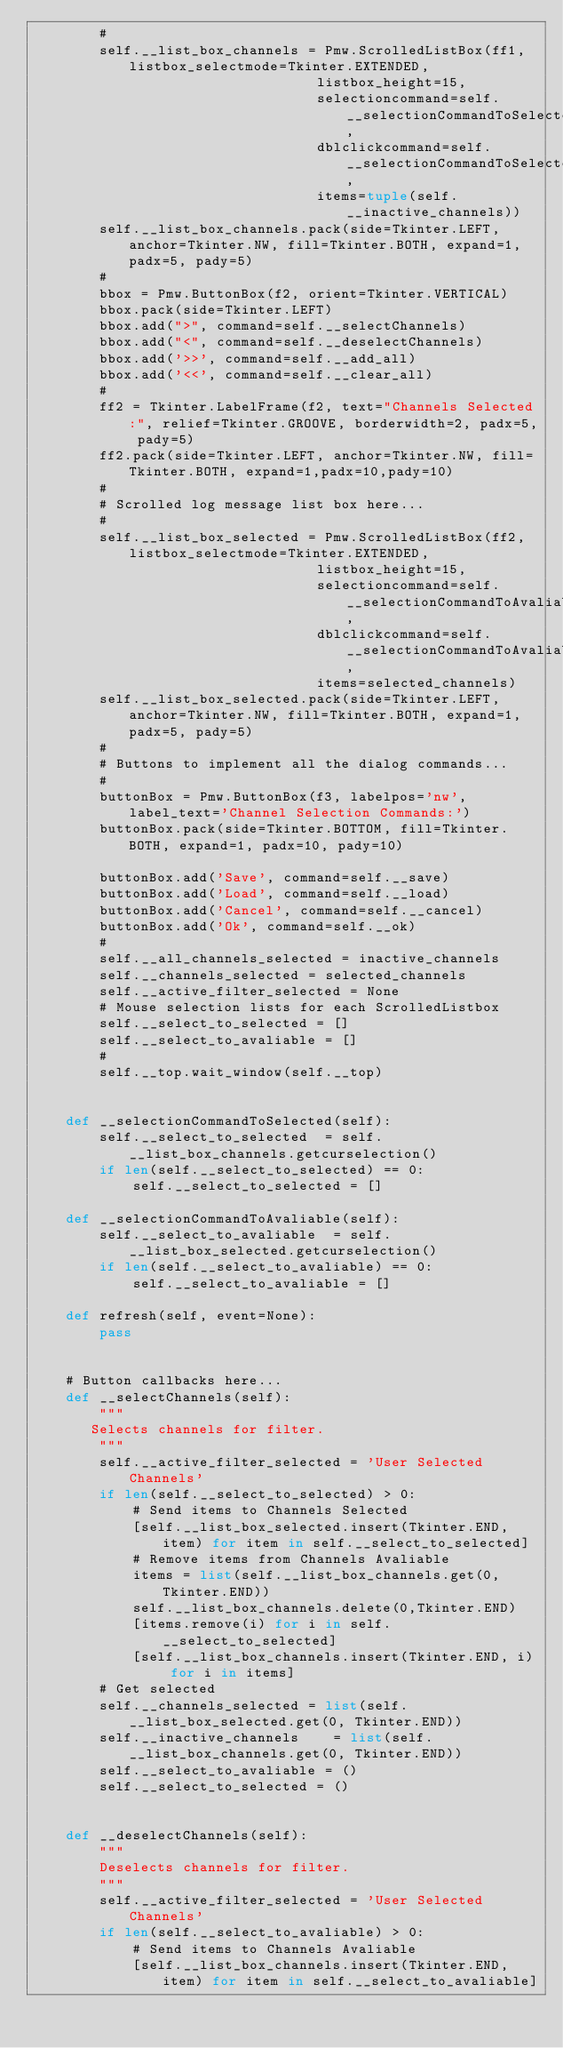<code> <loc_0><loc_0><loc_500><loc_500><_Python_>        #
        self.__list_box_channels = Pmw.ScrolledListBox(ff1, listbox_selectmode=Tkinter.EXTENDED,
                                  listbox_height=15,
                                  selectioncommand=self.__selectionCommandToSelected,
                                  dblclickcommand=self.__selectionCommandToSelected,
                                  items=tuple(self.__inactive_channels))
        self.__list_box_channels.pack(side=Tkinter.LEFT, anchor=Tkinter.NW, fill=Tkinter.BOTH, expand=1, padx=5, pady=5)
        #
        bbox = Pmw.ButtonBox(f2, orient=Tkinter.VERTICAL)
        bbox.pack(side=Tkinter.LEFT)
        bbox.add(">", command=self.__selectChannels)
        bbox.add("<", command=self.__deselectChannels)
        bbox.add('>>', command=self.__add_all)
        bbox.add('<<', command=self.__clear_all)
        #
        ff2 = Tkinter.LabelFrame(f2, text="Channels Selected:", relief=Tkinter.GROOVE, borderwidth=2, padx=5, pady=5)
        ff2.pack(side=Tkinter.LEFT, anchor=Tkinter.NW, fill=Tkinter.BOTH, expand=1,padx=10,pady=10)
        #
        # Scrolled log message list box here...
        #
        self.__list_box_selected = Pmw.ScrolledListBox(ff2, listbox_selectmode=Tkinter.EXTENDED,
                                  listbox_height=15,
                                  selectioncommand=self.__selectionCommandToAvaliable,
                                  dblclickcommand=self.__selectionCommandToAvaliable,
                                  items=selected_channels)
        self.__list_box_selected.pack(side=Tkinter.LEFT, anchor=Tkinter.NW, fill=Tkinter.BOTH, expand=1, padx=5, pady=5)
        #
        # Buttons to implement all the dialog commands...
        #
        buttonBox = Pmw.ButtonBox(f3, labelpos='nw', label_text='Channel Selection Commands:')
        buttonBox.pack(side=Tkinter.BOTTOM, fill=Tkinter.BOTH, expand=1, padx=10, pady=10)

        buttonBox.add('Save', command=self.__save)
        buttonBox.add('Load', command=self.__load)
        buttonBox.add('Cancel', command=self.__cancel)
        buttonBox.add('Ok', command=self.__ok)
        #
        self.__all_channels_selected = inactive_channels
        self.__channels_selected = selected_channels
        self.__active_filter_selected = None
        # Mouse selection lists for each ScrolledListbox
        self.__select_to_selected = []
        self.__select_to_avaliable = []
        #
        self.__top.wait_window(self.__top)


    def __selectionCommandToSelected(self):
        self.__select_to_selected  = self.__list_box_channels.getcurselection()
        if len(self.__select_to_selected) == 0:
            self.__select_to_selected = []

    def __selectionCommandToAvaliable(self):
        self.__select_to_avaliable  = self.__list_box_selected.getcurselection()
        if len(self.__select_to_avaliable) == 0:
            self.__select_to_avaliable = []

    def refresh(self, event=None):
        pass


    # Button callbacks here...
    def __selectChannels(self):
        """
       Selects channels for filter.
        """
        self.__active_filter_selected = 'User Selected Channels'
        if len(self.__select_to_selected) > 0:
            # Send items to Channels Selected
            [self.__list_box_selected.insert(Tkinter.END, item) for item in self.__select_to_selected]
            # Remove items from Channels Avaliable
            items = list(self.__list_box_channels.get(0, Tkinter.END))
            self.__list_box_channels.delete(0,Tkinter.END)
            [items.remove(i) for i in self.__select_to_selected]
            [self.__list_box_channels.insert(Tkinter.END, i) for i in items]
        # Get selected
        self.__channels_selected = list(self.__list_box_selected.get(0, Tkinter.END))
        self.__inactive_channels    = list(self.__list_box_channels.get(0, Tkinter.END))
        self.__select_to_avaliable = ()
        self.__select_to_selected = ()


    def __deselectChannels(self):
        """
        Deselects channels for filter.
        """
        self.__active_filter_selected = 'User Selected Channels'
        if len(self.__select_to_avaliable) > 0:
            # Send items to Channels Avaliable
            [self.__list_box_channels.insert(Tkinter.END, item) for item in self.__select_to_avaliable]</code> 